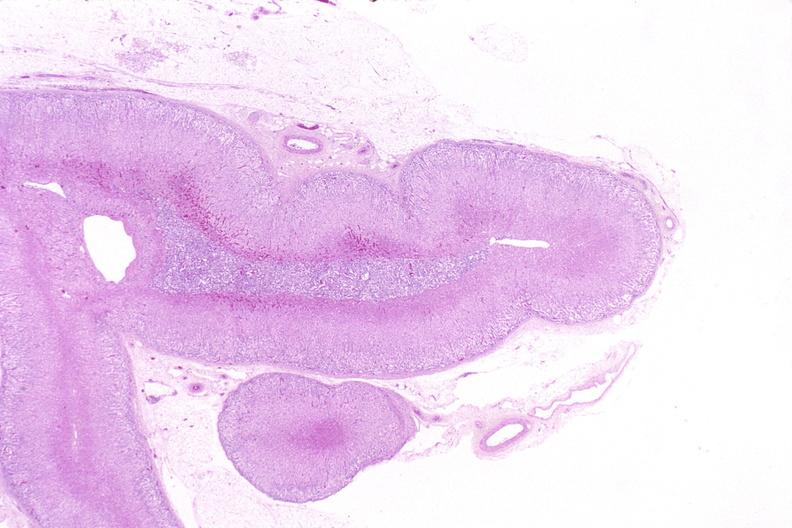does this image show adrenal gland, normal histology?
Answer the question using a single word or phrase. Yes 